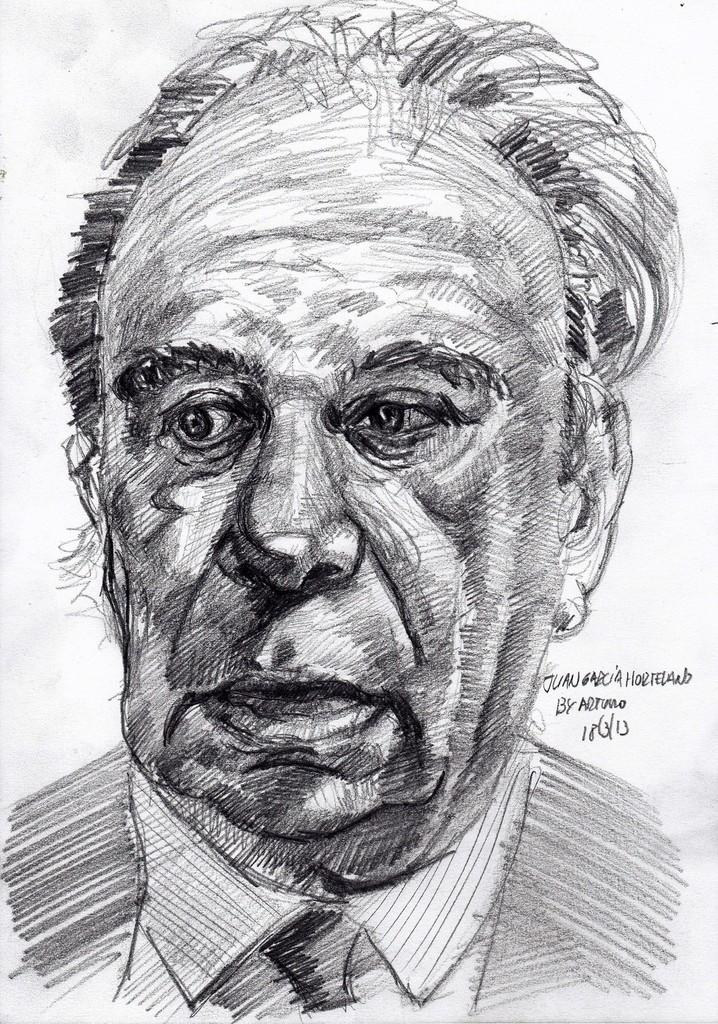What is the main subject of the image? The main subject of the image is a sketch of a person. Can you describe any additional elements in the image? Yes, there is some text on the right side of the image. What type of pencil is being used to draw the person in the image? There is no pencil visible in the image, as it is a sketch and not a drawing in progress. 